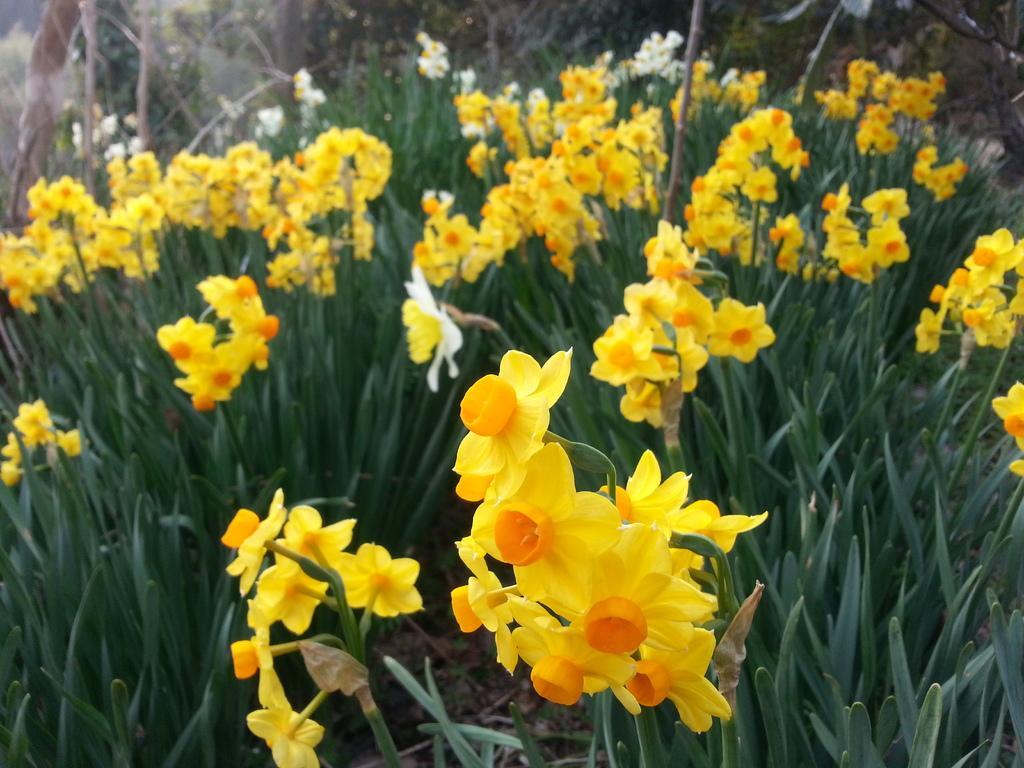Could you give a brief overview of what you see in this image? This picture is taken from outside of the city. In this image, we can see some plants with flowers which are in yellow color. 